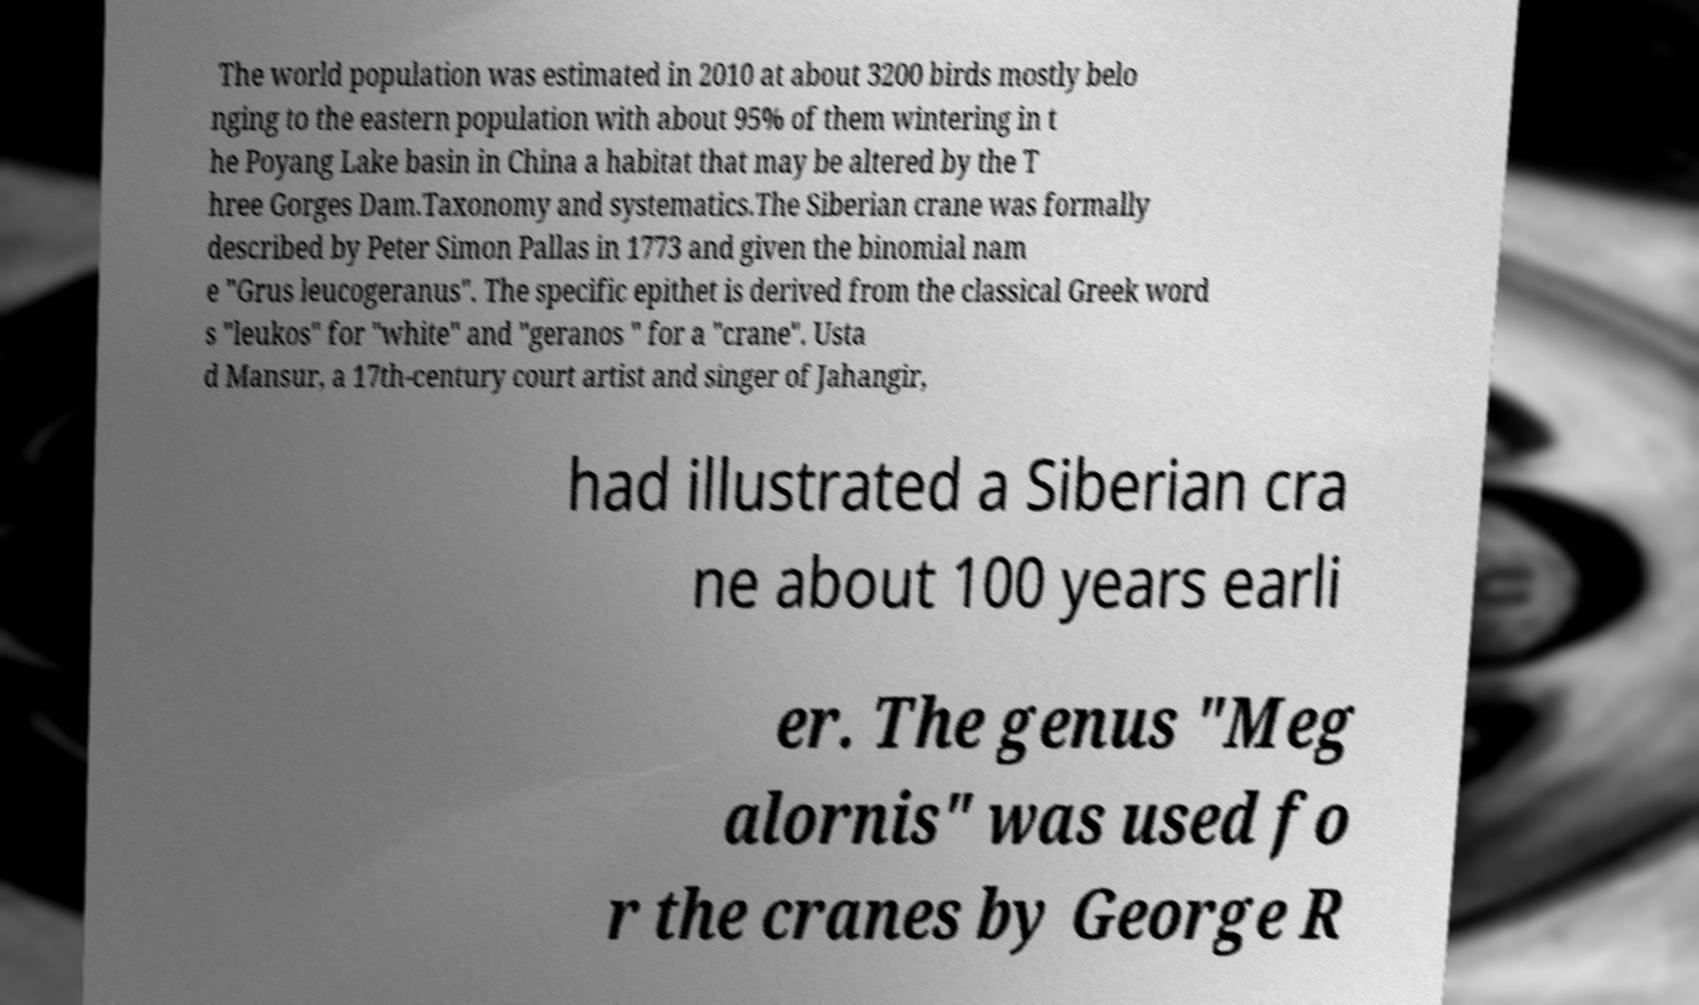Could you assist in decoding the text presented in this image and type it out clearly? The world population was estimated in 2010 at about 3200 birds mostly belo nging to the eastern population with about 95% of them wintering in t he Poyang Lake basin in China a habitat that may be altered by the T hree Gorges Dam.Taxonomy and systematics.The Siberian crane was formally described by Peter Simon Pallas in 1773 and given the binomial nam e "Grus leucogeranus". The specific epithet is derived from the classical Greek word s "leukos" for "white" and "geranos " for a "crane". Usta d Mansur, a 17th-century court artist and singer of Jahangir, had illustrated a Siberian cra ne about 100 years earli er. The genus "Meg alornis" was used fo r the cranes by George R 